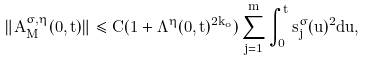<formula> <loc_0><loc_0><loc_500><loc_500>\| A ^ { \sigma , \eta } _ { M } ( 0 , t ) \| \leq C ( 1 + \Lambda ^ { \eta } ( 0 , t ) ^ { 2 k _ { o } } ) \sum _ { j = 1 } ^ { m } \int _ { 0 } ^ { t } s _ { j } ^ { \sigma } ( u ) ^ { 2 } d u ,</formula> 